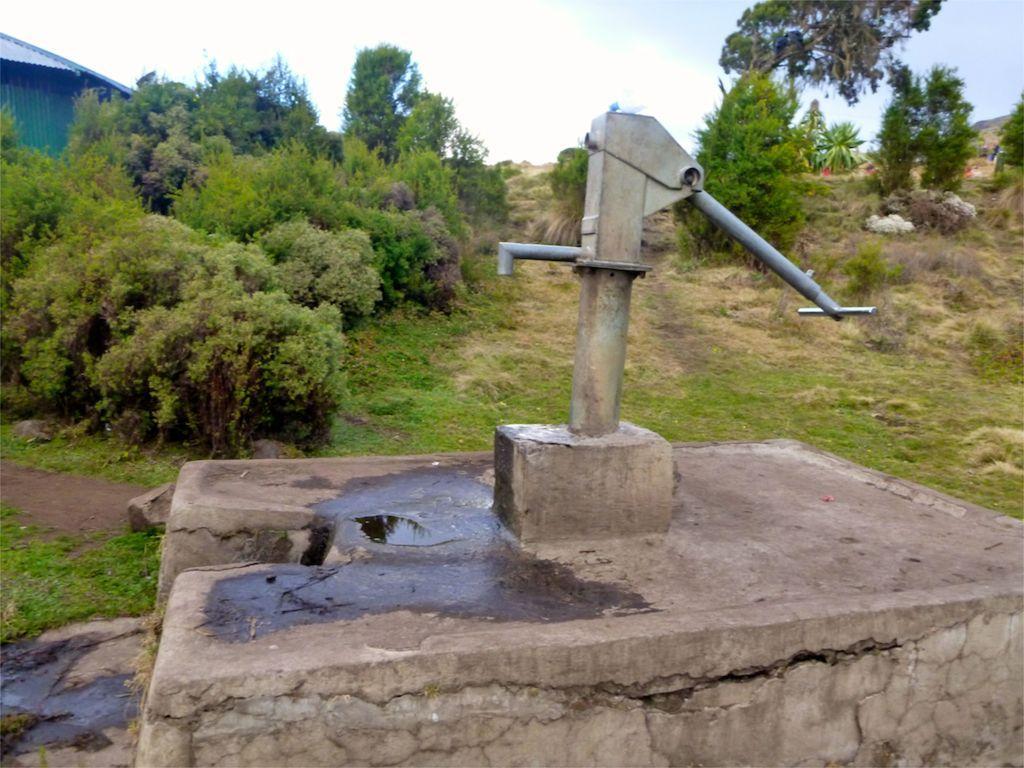Could you give a brief overview of what you see in this image? In this image, I can see a hand pump, trees and plants. On the left corner of the image, It looks like a shed. In the background, there is the sky. 